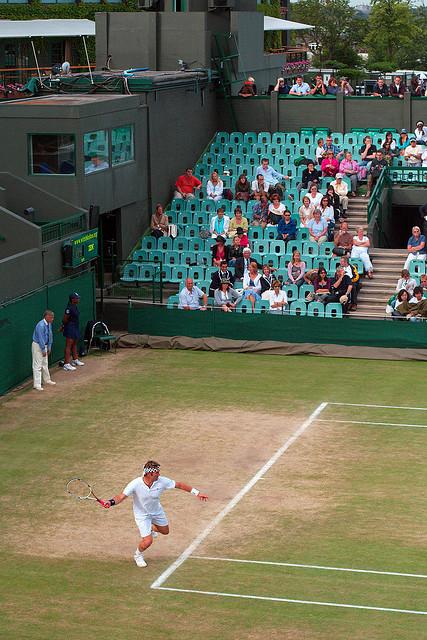Are there many fans watching the game?
Give a very brief answer. No. What is the game being played?
Give a very brief answer. Tennis. What color are the seats?
Answer briefly. Green. What sport is being played?
Be succinct. Tennis. What is this sport?
Concise answer only. Tennis. Why are there people watching the game?
Quick response, please. Entertainment. 